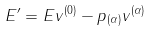<formula> <loc_0><loc_0><loc_500><loc_500>E ^ { \prime } = E v ^ { ( 0 ) } - p _ { ( \alpha ) } v ^ { ( \alpha ) }</formula> 